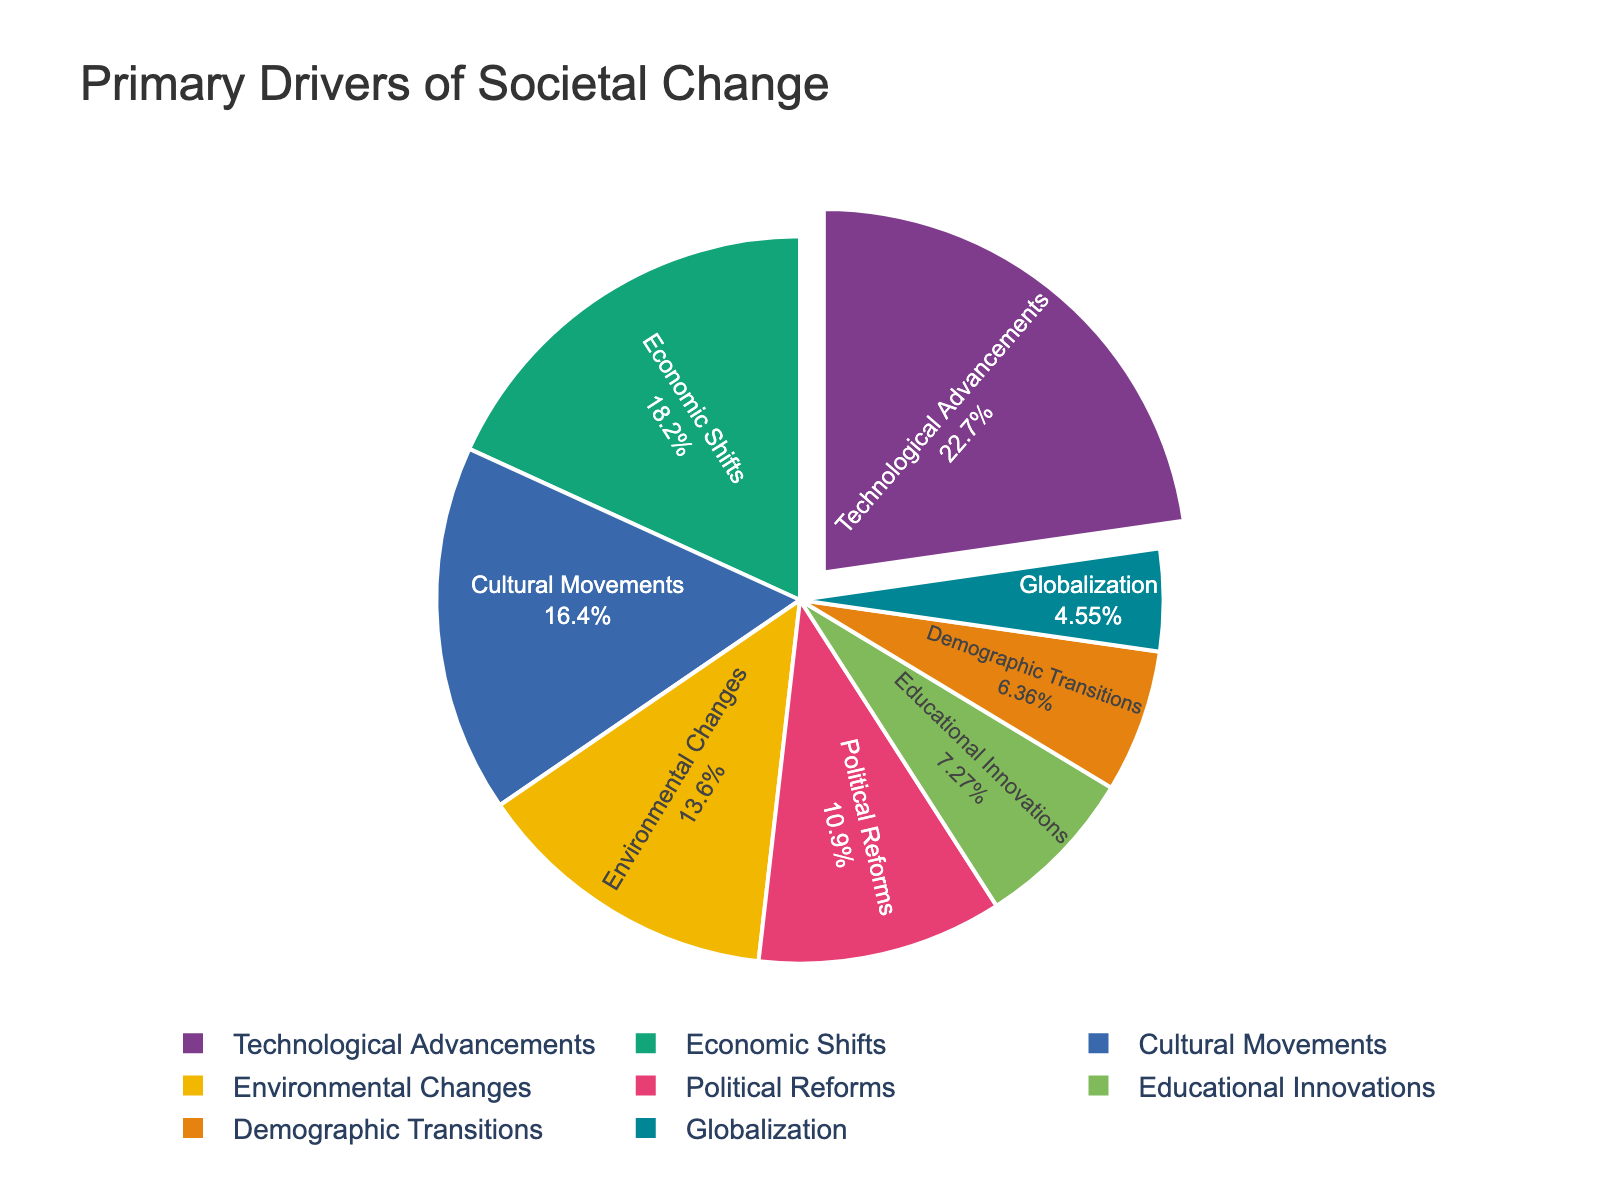Which driver is the largest contributor to societal change? The largest segment of the pie chart represents 25%, which is attributed to Technological Advancements.
Answer: Technological Advancements Which driver has the smallest contribution? The smallest segment of the pie chart, representing 5%, corresponds to Globalization.
Answer: Globalization How much more prominent are Technological Advancements compared to Globalization? Technological Advancements account for 25%, while Globalization accounts for 5%. The difference is 25% - 5% = 20%.
Answer: 20% Which drivers contribute more than 15%? Technological Advancements (25%), Economic Shifts (20%), Cultural Movements (18%) all contribute more than 15%.
Answer: Technological Advancements, Economic Shifts, Cultural Movements What is the combined contribution of Political Reforms and Educational Innovations? Political Reforms contribute 12%, while Educational Innovations contribute 8%. Their combined contribution is 12% + 8% = 20%.
Answer: 20% Which driver has the closest percentage to Cultural Movements? Cultural Movements contribute 18%, and the closest percentage is Economic Shifts which contribute 20%.
Answer: Economic Shifts How does the contribution of Environmental Changes compare to that of Demographic Transitions? Environmental Changes contribute 15%, while Demographic Transitions contribute 7%. Environmental Changes contribute 8% more.
Answer: 8% more What is the total percentage contributed by drivers focused on societal structures (i.e., Economic Shifts, Political Reforms, and Educational Innovations)? Economic Shifts contribute 20%, Political Reforms contribute 12%, and Educational Innovations contribute 8%. Their total contribution is 20% + 12% + 8% = 40%.
Answer: 40% Visually, which color represents Economic Shifts? In a custom color palette designed for the chart, Economic Shifts are often represented by a distinct color like green, blue, or red, considering it's the second largest section. The exact color needs to be identified from the palette applied.
Answer: (specific color based on chart) What is the average contribution of all drivers mentioned? Sum all percentages and count the number of drivers: (25 + 20 + 18 + 15 + 12 + 8 + 7 + 5) / 8 = 110 / 8 = 13.75%.
Answer: 13.75% 